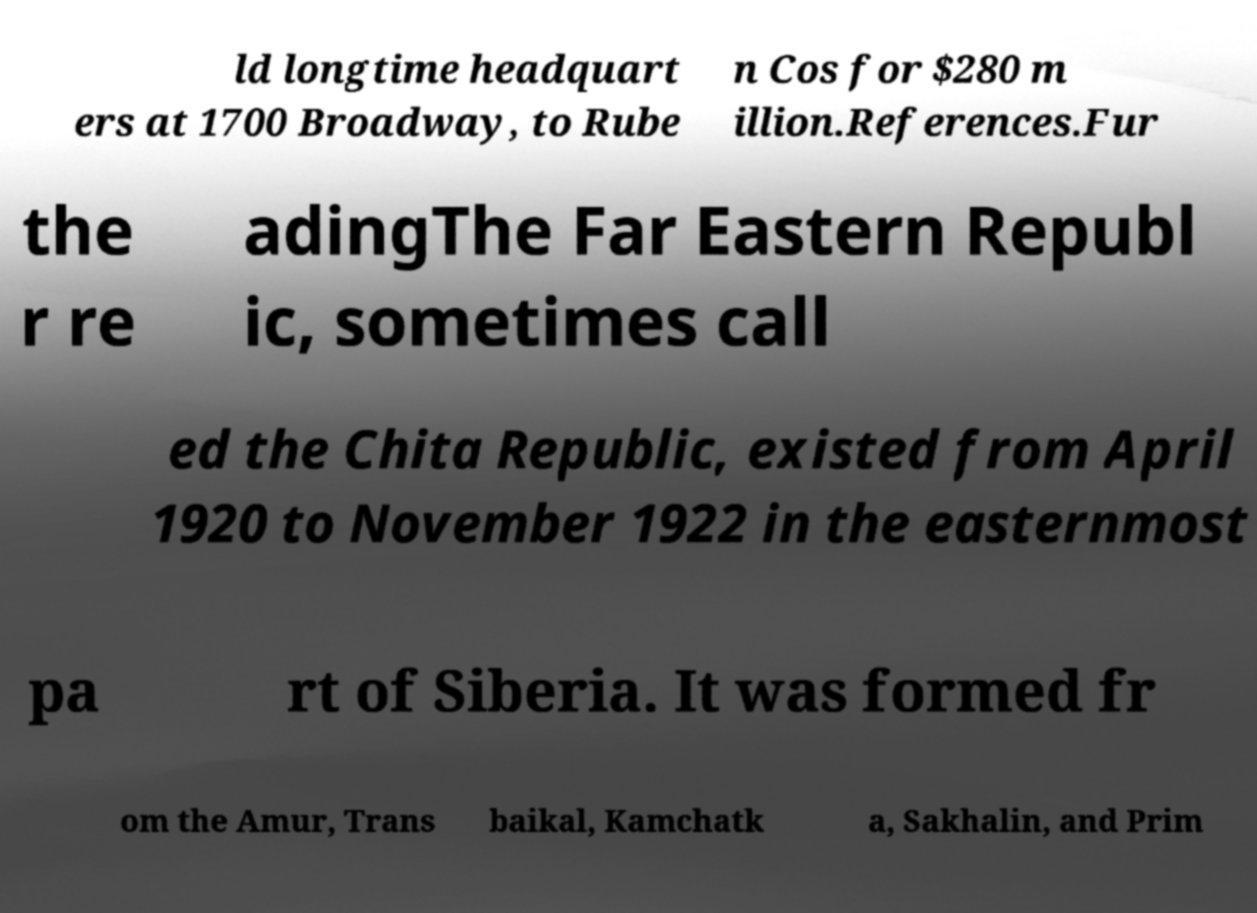Can you accurately transcribe the text from the provided image for me? ld longtime headquart ers at 1700 Broadway, to Rube n Cos for $280 m illion.References.Fur the r re adingThe Far Eastern Republ ic, sometimes call ed the Chita Republic, existed from April 1920 to November 1922 in the easternmost pa rt of Siberia. It was formed fr om the Amur, Trans baikal, Kamchatk a, Sakhalin, and Prim 